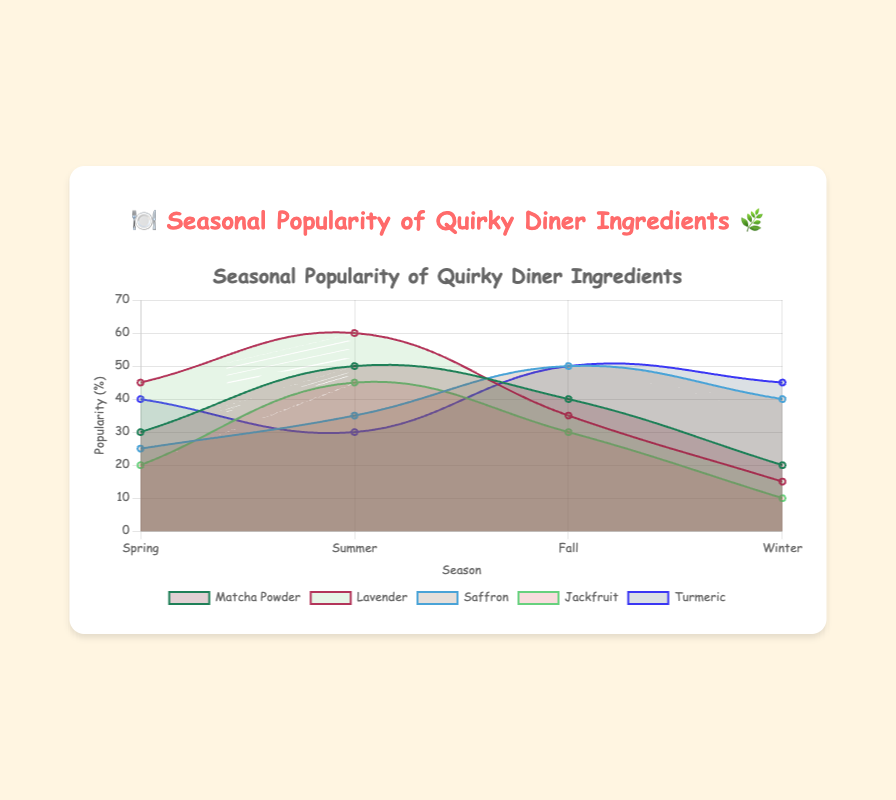What is the title of the chart? The title of the chart is displayed at the top of the figure in a larger and more prominent font. This element is typically easier to spot.
Answer: Seasonal Popularity of Quirky Diner Ingredients Which ingredient has the highest popularity in Summer? Look at the data points specifically in the Summer section and identify the ingredient with the highest value.
Answer: Lavender What is the overall trend for the popularity of Jackfruit across the seasons? Observe the line representing Jackfruit across the four seasons to determine if the value increases, decreases, or fluctuates.
Answer: It increases till Summer, then decreases How does the popularity of Turmeric in Winter compare to its popularity in Summer? Compare the data points for Turmeric during Winter and Summer. Notice the relative height of the points or the values if indicated numerically.
Answer: Higher in Winter Which ingredient shows the most consistent popularity throughout the year? Look at the lines of each ingredient and identify which one has less fluctuation across the different seasons.
Answer: Matcha Powder What is the combined popularity of Matcha Powder and Saffron in Fall? Sum the Fall popularity values of both Matcha Powder and Saffron. Matcha Powder in Fall is 40 and Saffron in Fall is 50, thus 40 + 50.
Answer: 90 How does the popularity of Lavender in Spring compare to that of Winter? Compare the values for Lavender in Spring and Winter and note the difference.
Answer: Higher in Spring Which ingredient's popularity drops the most from Summer to Winter? Determine the difference in popularity from Summer to Winter for each ingredient and find the maximum decrease.
Answer: Jackfruit What is the average popularity of all ingredients in Spring? Add up the Spring popularities and divide by the number of ingredients. The sum is (30 + 45 + 25 + 20 + 40) = 160, and dividing by 5 gives the average.
Answer: 32 Which ingredient is the least popular in Fall? Look at the Fall data points for each ingredient and identify the one with the lowest value.
Answer: Jackfruit 